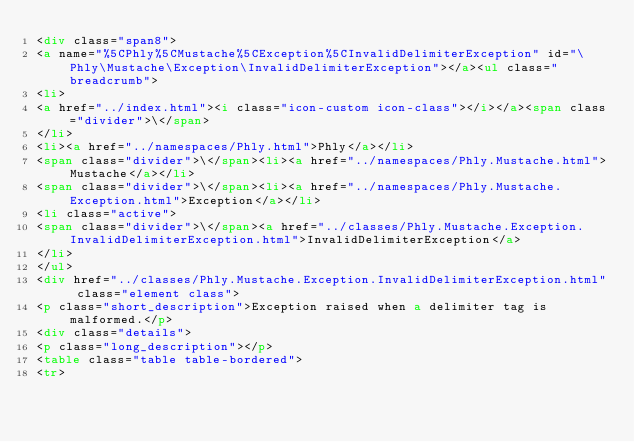<code> <loc_0><loc_0><loc_500><loc_500><_HTML_><div class="span8">
<a name="%5CPhly%5CMustache%5CException%5CInvalidDelimiterException" id="\Phly\Mustache\Exception\InvalidDelimiterException"></a><ul class="breadcrumb">
<li>
<a href="../index.html"><i class="icon-custom icon-class"></i></a><span class="divider">\</span>
</li>
<li><a href="../namespaces/Phly.html">Phly</a></li>
<span class="divider">\</span><li><a href="../namespaces/Phly.Mustache.html">Mustache</a></li>
<span class="divider">\</span><li><a href="../namespaces/Phly.Mustache.Exception.html">Exception</a></li>
<li class="active">
<span class="divider">\</span><a href="../classes/Phly.Mustache.Exception.InvalidDelimiterException.html">InvalidDelimiterException</a>
</li>
</ul>
<div href="../classes/Phly.Mustache.Exception.InvalidDelimiterException.html" class="element class">
<p class="short_description">Exception raised when a delimiter tag is malformed.</p>
<div class="details">
<p class="long_description"></p>
<table class="table table-bordered">
<tr></code> 